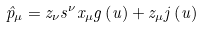Convert formula to latex. <formula><loc_0><loc_0><loc_500><loc_500>\hat { p } _ { \mu } = z _ { \nu } s ^ { \nu } x _ { \mu } g \left ( u \right ) + z _ { \mu } j \left ( u \right )</formula> 